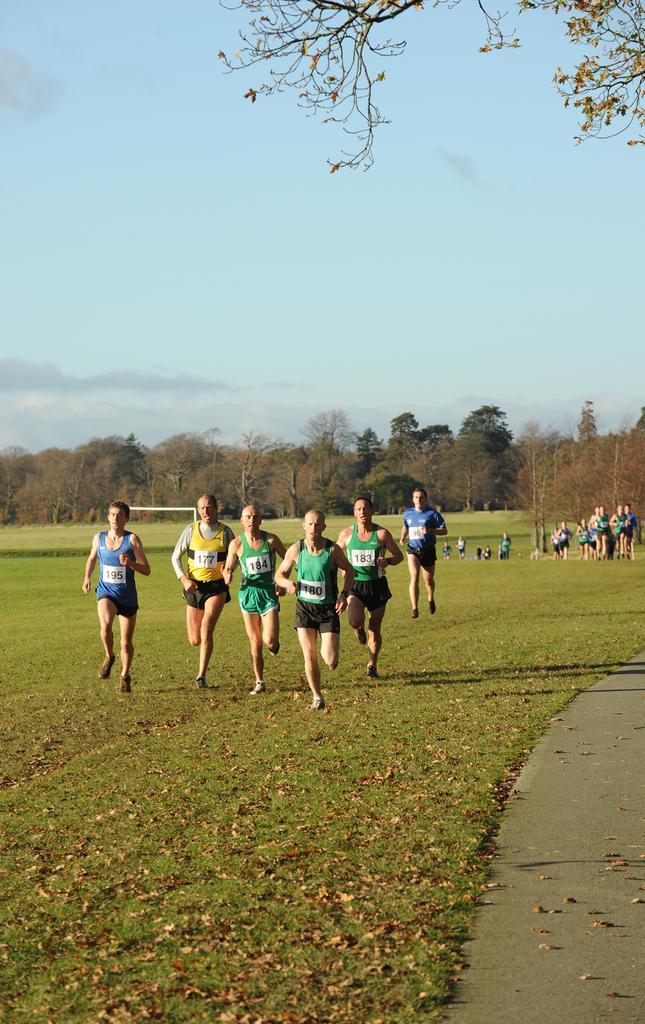Can you describe this image briefly? In this image we can see people running on the grass. In the background we can see many trees. There is also a sky with the clouds. At the bottom we can see the road and also dried leaves. 